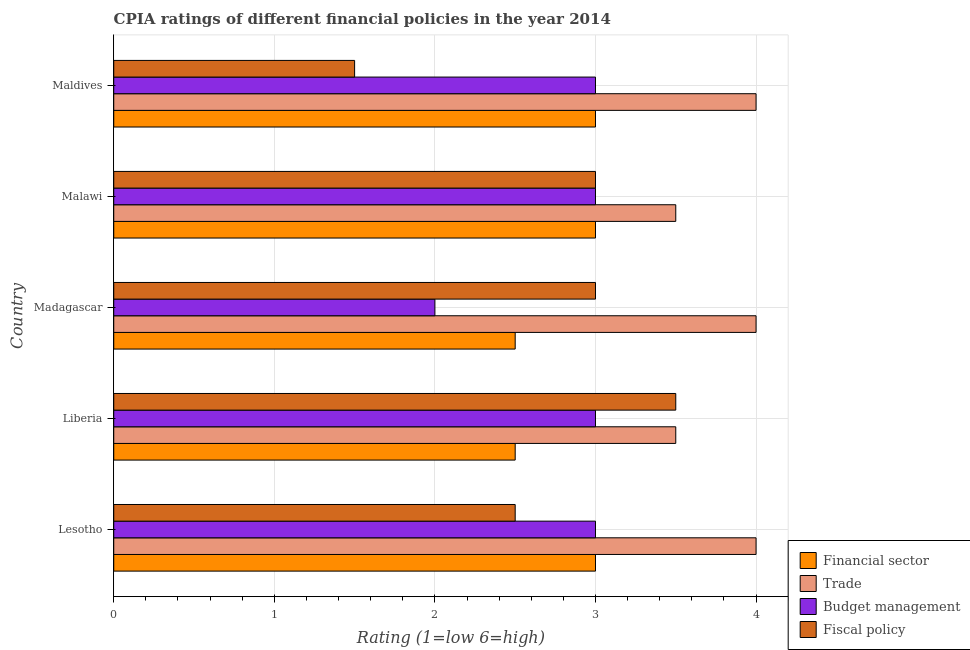How many groups of bars are there?
Your response must be concise. 5. Are the number of bars per tick equal to the number of legend labels?
Give a very brief answer. Yes. Are the number of bars on each tick of the Y-axis equal?
Your answer should be very brief. Yes. How many bars are there on the 2nd tick from the top?
Your answer should be compact. 4. What is the label of the 3rd group of bars from the top?
Your answer should be compact. Madagascar. What is the cpia rating of budget management in Madagascar?
Ensure brevity in your answer.  2. In which country was the cpia rating of trade maximum?
Your response must be concise. Lesotho. In which country was the cpia rating of trade minimum?
Make the answer very short. Liberia. What is the total cpia rating of fiscal policy in the graph?
Keep it short and to the point. 13.5. What is the difference between the cpia rating of financial sector in Madagascar and the cpia rating of budget management in Liberia?
Your response must be concise. -0.5. What is the difference between the cpia rating of trade and cpia rating of fiscal policy in Madagascar?
Offer a very short reply. 1. In how many countries, is the cpia rating of budget management greater than 1.8 ?
Offer a terse response. 5. Is the cpia rating of trade in Lesotho less than that in Maldives?
Make the answer very short. No. What is the difference between the highest and the second highest cpia rating of budget management?
Provide a succinct answer. 0. What is the difference between the highest and the lowest cpia rating of financial sector?
Ensure brevity in your answer.  0.5. In how many countries, is the cpia rating of budget management greater than the average cpia rating of budget management taken over all countries?
Your answer should be compact. 4. Is the sum of the cpia rating of financial sector in Lesotho and Liberia greater than the maximum cpia rating of fiscal policy across all countries?
Provide a succinct answer. Yes. What does the 2nd bar from the top in Liberia represents?
Make the answer very short. Budget management. What does the 1st bar from the bottom in Liberia represents?
Provide a short and direct response. Financial sector. How many bars are there?
Offer a terse response. 20. How many countries are there in the graph?
Ensure brevity in your answer.  5. What is the difference between two consecutive major ticks on the X-axis?
Provide a short and direct response. 1. Are the values on the major ticks of X-axis written in scientific E-notation?
Give a very brief answer. No. Does the graph contain grids?
Offer a terse response. Yes. How many legend labels are there?
Keep it short and to the point. 4. What is the title of the graph?
Your answer should be very brief. CPIA ratings of different financial policies in the year 2014. What is the label or title of the X-axis?
Make the answer very short. Rating (1=low 6=high). What is the Rating (1=low 6=high) of Budget management in Lesotho?
Give a very brief answer. 3. What is the Rating (1=low 6=high) in Financial sector in Liberia?
Your answer should be compact. 2.5. What is the Rating (1=low 6=high) of Trade in Liberia?
Make the answer very short. 3.5. What is the Rating (1=low 6=high) in Financial sector in Madagascar?
Your answer should be very brief. 2.5. What is the Rating (1=low 6=high) in Budget management in Madagascar?
Offer a terse response. 2. What is the Rating (1=low 6=high) in Budget management in Malawi?
Provide a short and direct response. 3. What is the Rating (1=low 6=high) in Fiscal policy in Malawi?
Keep it short and to the point. 3. What is the Rating (1=low 6=high) in Financial sector in Maldives?
Provide a short and direct response. 3. What is the Rating (1=low 6=high) in Fiscal policy in Maldives?
Your answer should be very brief. 1.5. Across all countries, what is the minimum Rating (1=low 6=high) of Fiscal policy?
Provide a short and direct response. 1.5. What is the total Rating (1=low 6=high) of Financial sector in the graph?
Provide a short and direct response. 14. What is the total Rating (1=low 6=high) in Trade in the graph?
Keep it short and to the point. 19. What is the total Rating (1=low 6=high) of Budget management in the graph?
Your answer should be very brief. 14. What is the difference between the Rating (1=low 6=high) in Financial sector in Lesotho and that in Liberia?
Your response must be concise. 0.5. What is the difference between the Rating (1=low 6=high) of Trade in Lesotho and that in Liberia?
Keep it short and to the point. 0.5. What is the difference between the Rating (1=low 6=high) in Financial sector in Lesotho and that in Madagascar?
Your response must be concise. 0.5. What is the difference between the Rating (1=low 6=high) of Trade in Lesotho and that in Madagascar?
Your answer should be compact. 0. What is the difference between the Rating (1=low 6=high) of Fiscal policy in Lesotho and that in Madagascar?
Your answer should be compact. -0.5. What is the difference between the Rating (1=low 6=high) of Trade in Lesotho and that in Malawi?
Make the answer very short. 0.5. What is the difference between the Rating (1=low 6=high) of Fiscal policy in Lesotho and that in Malawi?
Provide a succinct answer. -0.5. What is the difference between the Rating (1=low 6=high) in Trade in Lesotho and that in Maldives?
Your answer should be very brief. 0. What is the difference between the Rating (1=low 6=high) of Budget management in Lesotho and that in Maldives?
Keep it short and to the point. 0. What is the difference between the Rating (1=low 6=high) of Financial sector in Liberia and that in Madagascar?
Provide a succinct answer. 0. What is the difference between the Rating (1=low 6=high) of Financial sector in Liberia and that in Malawi?
Ensure brevity in your answer.  -0.5. What is the difference between the Rating (1=low 6=high) in Budget management in Liberia and that in Malawi?
Make the answer very short. 0. What is the difference between the Rating (1=low 6=high) of Fiscal policy in Liberia and that in Malawi?
Provide a succinct answer. 0.5. What is the difference between the Rating (1=low 6=high) of Financial sector in Liberia and that in Maldives?
Your response must be concise. -0.5. What is the difference between the Rating (1=low 6=high) in Trade in Liberia and that in Maldives?
Your answer should be very brief. -0.5. What is the difference between the Rating (1=low 6=high) of Budget management in Liberia and that in Maldives?
Offer a terse response. 0. What is the difference between the Rating (1=low 6=high) in Fiscal policy in Liberia and that in Maldives?
Offer a terse response. 2. What is the difference between the Rating (1=low 6=high) of Financial sector in Madagascar and that in Maldives?
Your answer should be very brief. -0.5. What is the difference between the Rating (1=low 6=high) of Trade in Madagascar and that in Maldives?
Provide a short and direct response. 0. What is the difference between the Rating (1=low 6=high) in Fiscal policy in Madagascar and that in Maldives?
Your answer should be compact. 1.5. What is the difference between the Rating (1=low 6=high) of Fiscal policy in Malawi and that in Maldives?
Provide a succinct answer. 1.5. What is the difference between the Rating (1=low 6=high) in Financial sector in Lesotho and the Rating (1=low 6=high) in Fiscal policy in Liberia?
Give a very brief answer. -0.5. What is the difference between the Rating (1=low 6=high) of Trade in Lesotho and the Rating (1=low 6=high) of Budget management in Liberia?
Your answer should be compact. 1. What is the difference between the Rating (1=low 6=high) of Budget management in Lesotho and the Rating (1=low 6=high) of Fiscal policy in Liberia?
Your answer should be very brief. -0.5. What is the difference between the Rating (1=low 6=high) in Financial sector in Lesotho and the Rating (1=low 6=high) in Trade in Madagascar?
Keep it short and to the point. -1. What is the difference between the Rating (1=low 6=high) of Financial sector in Lesotho and the Rating (1=low 6=high) of Trade in Malawi?
Make the answer very short. -0.5. What is the difference between the Rating (1=low 6=high) in Financial sector in Lesotho and the Rating (1=low 6=high) in Budget management in Malawi?
Your answer should be very brief. 0. What is the difference between the Rating (1=low 6=high) of Budget management in Lesotho and the Rating (1=low 6=high) of Fiscal policy in Malawi?
Your answer should be very brief. 0. What is the difference between the Rating (1=low 6=high) in Financial sector in Lesotho and the Rating (1=low 6=high) in Trade in Maldives?
Keep it short and to the point. -1. What is the difference between the Rating (1=low 6=high) in Financial sector in Lesotho and the Rating (1=low 6=high) in Budget management in Maldives?
Your answer should be very brief. 0. What is the difference between the Rating (1=low 6=high) of Financial sector in Lesotho and the Rating (1=low 6=high) of Fiscal policy in Maldives?
Ensure brevity in your answer.  1.5. What is the difference between the Rating (1=low 6=high) in Trade in Lesotho and the Rating (1=low 6=high) in Budget management in Maldives?
Your answer should be compact. 1. What is the difference between the Rating (1=low 6=high) in Trade in Lesotho and the Rating (1=low 6=high) in Fiscal policy in Maldives?
Provide a succinct answer. 2.5. What is the difference between the Rating (1=low 6=high) in Budget management in Lesotho and the Rating (1=low 6=high) in Fiscal policy in Maldives?
Offer a very short reply. 1.5. What is the difference between the Rating (1=low 6=high) of Financial sector in Liberia and the Rating (1=low 6=high) of Trade in Madagascar?
Ensure brevity in your answer.  -1.5. What is the difference between the Rating (1=low 6=high) of Financial sector in Liberia and the Rating (1=low 6=high) of Fiscal policy in Madagascar?
Your response must be concise. -0.5. What is the difference between the Rating (1=low 6=high) in Trade in Liberia and the Rating (1=low 6=high) in Budget management in Madagascar?
Give a very brief answer. 1.5. What is the difference between the Rating (1=low 6=high) in Trade in Liberia and the Rating (1=low 6=high) in Fiscal policy in Madagascar?
Provide a succinct answer. 0.5. What is the difference between the Rating (1=low 6=high) of Budget management in Liberia and the Rating (1=low 6=high) of Fiscal policy in Madagascar?
Ensure brevity in your answer.  0. What is the difference between the Rating (1=low 6=high) in Financial sector in Liberia and the Rating (1=low 6=high) in Trade in Malawi?
Keep it short and to the point. -1. What is the difference between the Rating (1=low 6=high) in Financial sector in Liberia and the Rating (1=low 6=high) in Budget management in Maldives?
Provide a succinct answer. -0.5. What is the difference between the Rating (1=low 6=high) in Financial sector in Liberia and the Rating (1=low 6=high) in Fiscal policy in Maldives?
Offer a very short reply. 1. What is the difference between the Rating (1=low 6=high) of Trade in Liberia and the Rating (1=low 6=high) of Fiscal policy in Maldives?
Your answer should be very brief. 2. What is the difference between the Rating (1=low 6=high) of Trade in Madagascar and the Rating (1=low 6=high) of Fiscal policy in Malawi?
Your answer should be very brief. 1. What is the difference between the Rating (1=low 6=high) in Budget management in Madagascar and the Rating (1=low 6=high) in Fiscal policy in Malawi?
Provide a succinct answer. -1. What is the difference between the Rating (1=low 6=high) in Financial sector in Madagascar and the Rating (1=low 6=high) in Trade in Maldives?
Give a very brief answer. -1.5. What is the difference between the Rating (1=low 6=high) in Trade in Madagascar and the Rating (1=low 6=high) in Fiscal policy in Maldives?
Make the answer very short. 2.5. What is the difference between the Rating (1=low 6=high) of Budget management in Madagascar and the Rating (1=low 6=high) of Fiscal policy in Maldives?
Offer a terse response. 0.5. What is the difference between the Rating (1=low 6=high) of Financial sector in Malawi and the Rating (1=low 6=high) of Budget management in Maldives?
Ensure brevity in your answer.  0. What is the difference between the Rating (1=low 6=high) of Trade in Malawi and the Rating (1=low 6=high) of Budget management in Maldives?
Your answer should be very brief. 0.5. What is the difference between the Rating (1=low 6=high) of Financial sector and Rating (1=low 6=high) of Budget management in Lesotho?
Ensure brevity in your answer.  0. What is the difference between the Rating (1=low 6=high) in Financial sector and Rating (1=low 6=high) in Fiscal policy in Lesotho?
Your response must be concise. 0.5. What is the difference between the Rating (1=low 6=high) of Trade and Rating (1=low 6=high) of Fiscal policy in Lesotho?
Ensure brevity in your answer.  1.5. What is the difference between the Rating (1=low 6=high) in Budget management and Rating (1=low 6=high) in Fiscal policy in Lesotho?
Give a very brief answer. 0.5. What is the difference between the Rating (1=low 6=high) in Financial sector and Rating (1=low 6=high) in Trade in Liberia?
Make the answer very short. -1. What is the difference between the Rating (1=low 6=high) in Financial sector and Rating (1=low 6=high) in Budget management in Liberia?
Provide a short and direct response. -0.5. What is the difference between the Rating (1=low 6=high) of Trade and Rating (1=low 6=high) of Fiscal policy in Liberia?
Provide a succinct answer. 0. What is the difference between the Rating (1=low 6=high) of Financial sector and Rating (1=low 6=high) of Trade in Madagascar?
Your answer should be very brief. -1.5. What is the difference between the Rating (1=low 6=high) in Trade and Rating (1=low 6=high) in Fiscal policy in Madagascar?
Offer a terse response. 1. What is the difference between the Rating (1=low 6=high) of Financial sector and Rating (1=low 6=high) of Trade in Malawi?
Keep it short and to the point. -0.5. What is the difference between the Rating (1=low 6=high) of Financial sector and Rating (1=low 6=high) of Budget management in Malawi?
Ensure brevity in your answer.  0. What is the difference between the Rating (1=low 6=high) of Financial sector and Rating (1=low 6=high) of Fiscal policy in Malawi?
Provide a short and direct response. 0. What is the difference between the Rating (1=low 6=high) of Trade and Rating (1=low 6=high) of Budget management in Malawi?
Your answer should be compact. 0.5. What is the difference between the Rating (1=low 6=high) of Trade and Rating (1=low 6=high) of Fiscal policy in Malawi?
Your answer should be very brief. 0.5. What is the difference between the Rating (1=low 6=high) in Budget management and Rating (1=low 6=high) in Fiscal policy in Malawi?
Your answer should be compact. 0. What is the difference between the Rating (1=low 6=high) in Financial sector and Rating (1=low 6=high) in Budget management in Maldives?
Your answer should be very brief. 0. What is the difference between the Rating (1=low 6=high) in Financial sector and Rating (1=low 6=high) in Fiscal policy in Maldives?
Keep it short and to the point. 1.5. What is the difference between the Rating (1=low 6=high) in Budget management and Rating (1=low 6=high) in Fiscal policy in Maldives?
Offer a terse response. 1.5. What is the ratio of the Rating (1=low 6=high) of Financial sector in Lesotho to that in Liberia?
Make the answer very short. 1.2. What is the ratio of the Rating (1=low 6=high) of Budget management in Lesotho to that in Liberia?
Your answer should be very brief. 1. What is the ratio of the Rating (1=low 6=high) in Fiscal policy in Lesotho to that in Liberia?
Your answer should be very brief. 0.71. What is the ratio of the Rating (1=low 6=high) in Financial sector in Lesotho to that in Malawi?
Ensure brevity in your answer.  1. What is the ratio of the Rating (1=low 6=high) of Financial sector in Lesotho to that in Maldives?
Your response must be concise. 1. What is the ratio of the Rating (1=low 6=high) in Financial sector in Liberia to that in Madagascar?
Your response must be concise. 1. What is the ratio of the Rating (1=low 6=high) in Financial sector in Liberia to that in Malawi?
Give a very brief answer. 0.83. What is the ratio of the Rating (1=low 6=high) in Budget management in Liberia to that in Malawi?
Offer a terse response. 1. What is the ratio of the Rating (1=low 6=high) of Fiscal policy in Liberia to that in Malawi?
Provide a succinct answer. 1.17. What is the ratio of the Rating (1=low 6=high) in Trade in Liberia to that in Maldives?
Your answer should be very brief. 0.88. What is the ratio of the Rating (1=low 6=high) of Fiscal policy in Liberia to that in Maldives?
Your answer should be compact. 2.33. What is the ratio of the Rating (1=low 6=high) in Budget management in Madagascar to that in Malawi?
Offer a very short reply. 0.67. What is the ratio of the Rating (1=low 6=high) in Financial sector in Madagascar to that in Maldives?
Provide a succinct answer. 0.83. What is the ratio of the Rating (1=low 6=high) in Trade in Madagascar to that in Maldives?
Give a very brief answer. 1. What is the ratio of the Rating (1=low 6=high) in Fiscal policy in Madagascar to that in Maldives?
Your answer should be very brief. 2. What is the ratio of the Rating (1=low 6=high) of Financial sector in Malawi to that in Maldives?
Provide a succinct answer. 1. What is the ratio of the Rating (1=low 6=high) of Trade in Malawi to that in Maldives?
Provide a succinct answer. 0.88. What is the ratio of the Rating (1=low 6=high) in Budget management in Malawi to that in Maldives?
Your answer should be compact. 1. What is the difference between the highest and the second highest Rating (1=low 6=high) of Financial sector?
Your answer should be very brief. 0. What is the difference between the highest and the second highest Rating (1=low 6=high) in Fiscal policy?
Provide a succinct answer. 0.5. What is the difference between the highest and the lowest Rating (1=low 6=high) in Fiscal policy?
Keep it short and to the point. 2. 